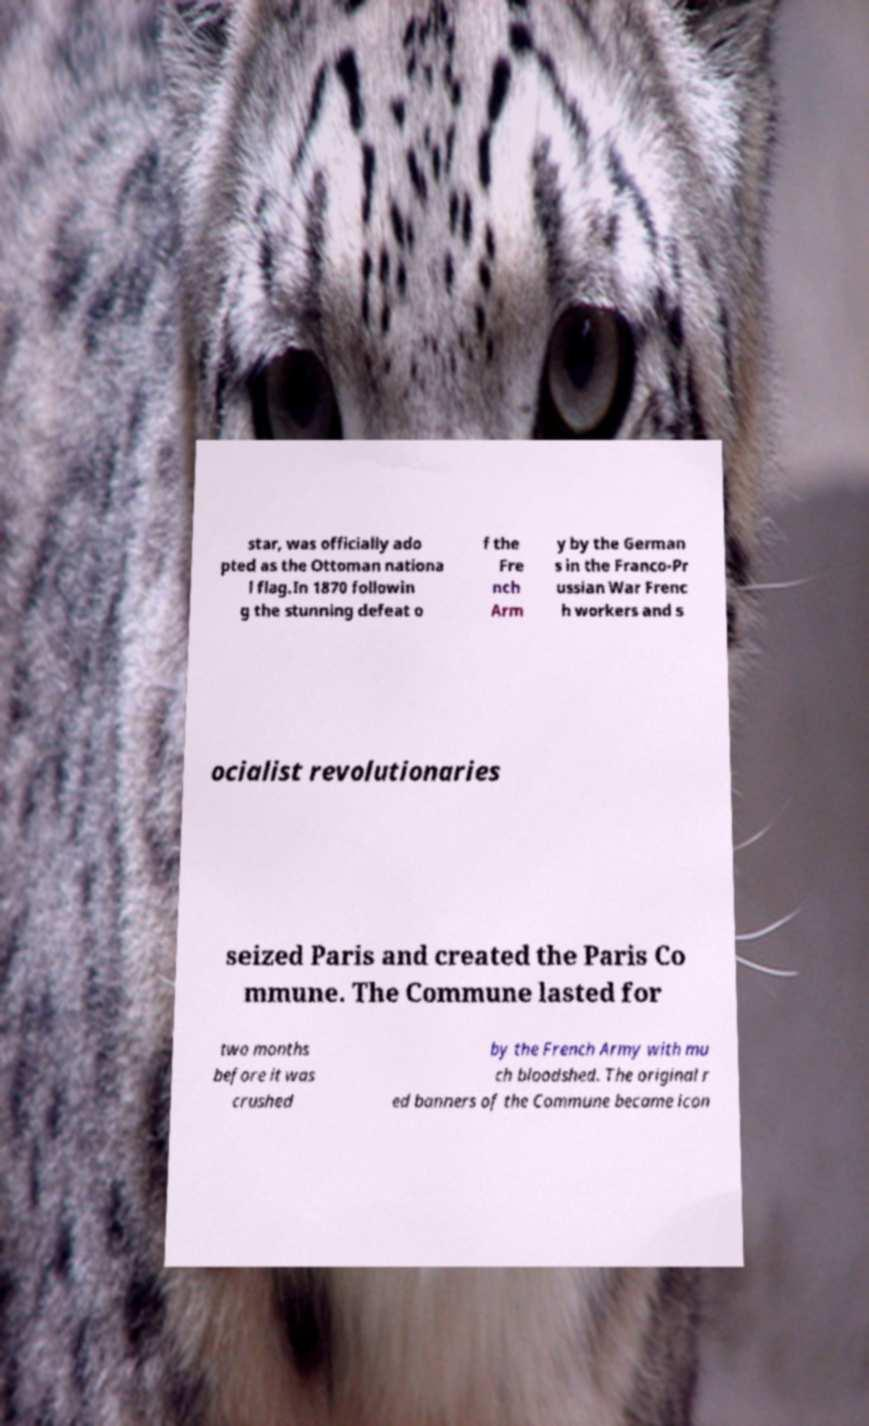There's text embedded in this image that I need extracted. Can you transcribe it verbatim? star, was officially ado pted as the Ottoman nationa l flag.In 1870 followin g the stunning defeat o f the Fre nch Arm y by the German s in the Franco-Pr ussian War Frenc h workers and s ocialist revolutionaries seized Paris and created the Paris Co mmune. The Commune lasted for two months before it was crushed by the French Army with mu ch bloodshed. The original r ed banners of the Commune became icon 